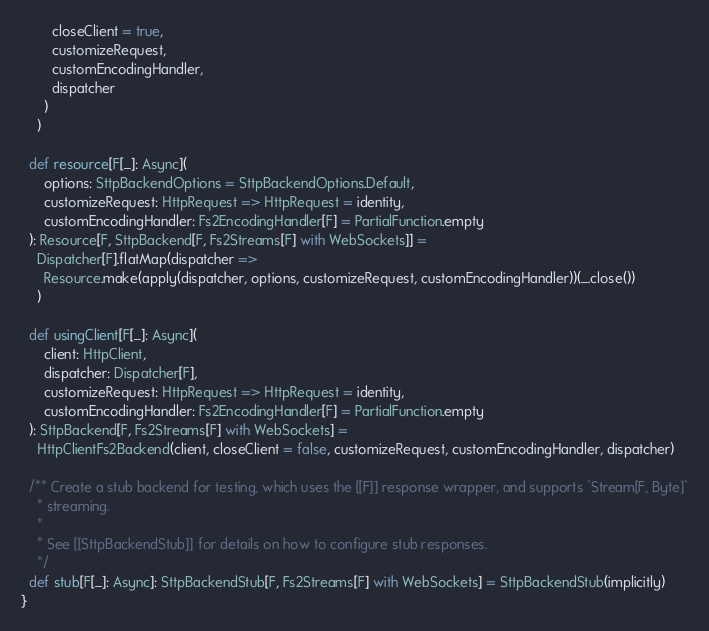Convert code to text. <code><loc_0><loc_0><loc_500><loc_500><_Scala_>        closeClient = true,
        customizeRequest,
        customEncodingHandler,
        dispatcher
      )
    )

  def resource[F[_]: Async](
      options: SttpBackendOptions = SttpBackendOptions.Default,
      customizeRequest: HttpRequest => HttpRequest = identity,
      customEncodingHandler: Fs2EncodingHandler[F] = PartialFunction.empty
  ): Resource[F, SttpBackend[F, Fs2Streams[F] with WebSockets]] =
    Dispatcher[F].flatMap(dispatcher =>
      Resource.make(apply(dispatcher, options, customizeRequest, customEncodingHandler))(_.close())
    )

  def usingClient[F[_]: Async](
      client: HttpClient,
      dispatcher: Dispatcher[F],
      customizeRequest: HttpRequest => HttpRequest = identity,
      customEncodingHandler: Fs2EncodingHandler[F] = PartialFunction.empty
  ): SttpBackend[F, Fs2Streams[F] with WebSockets] =
    HttpClientFs2Backend(client, closeClient = false, customizeRequest, customEncodingHandler, dispatcher)

  /** Create a stub backend for testing, which uses the [[F]] response wrapper, and supports `Stream[F, Byte]`
    * streaming.
    *
    * See [[SttpBackendStub]] for details on how to configure stub responses.
    */
  def stub[F[_]: Async]: SttpBackendStub[F, Fs2Streams[F] with WebSockets] = SttpBackendStub(implicitly)
}
</code> 